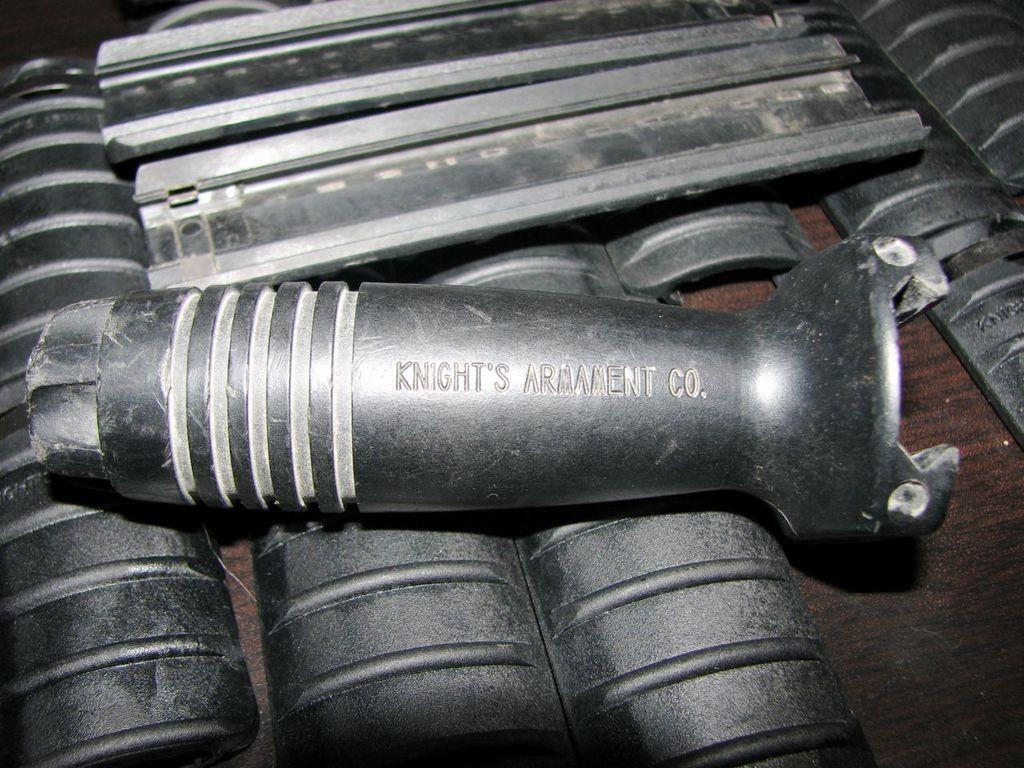Could you give a brief overview of what you see in this image? At the bottom of the image we can see a table, on the table we can see some metal objects. 